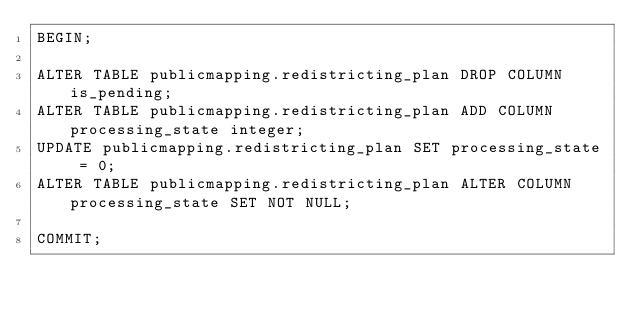Convert code to text. <code><loc_0><loc_0><loc_500><loc_500><_SQL_>BEGIN;

ALTER TABLE publicmapping.redistricting_plan DROP COLUMN is_pending;
ALTER TABLE publicmapping.redistricting_plan ADD COLUMN processing_state integer;
UPDATE publicmapping.redistricting_plan SET processing_state = 0;
ALTER TABLE publicmapping.redistricting_plan ALTER COLUMN processing_state SET NOT NULL;

COMMIT;
</code> 